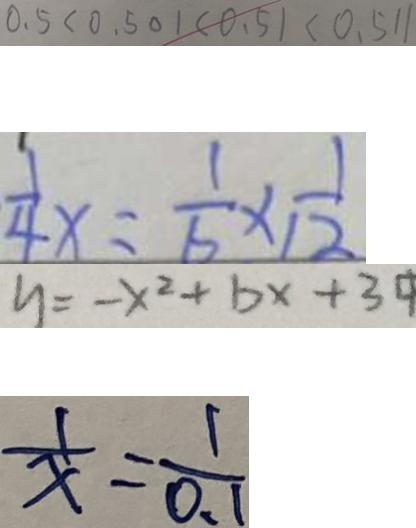Convert formula to latex. <formula><loc_0><loc_0><loc_500><loc_500>0 . 5 < 0 . 5 0 1 < 0 . 5 1 < 0 . 5 1 1 
 \frac { 1 } { 4 } x = \frac { 1 } { 6 } \times \frac { 1 } { 1 2 } 
 y = - x ^ { 2 } + b x + 3 
 \frac { 1 } { x } = \frac { 1 } { 0 . 1 }</formula> 